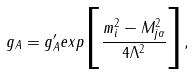<formula> <loc_0><loc_0><loc_500><loc_500>g _ { A } = g _ { A } ^ { \prime } e x p \Big { [ } \frac { m ^ { 2 } _ { i } - M ^ { 2 } _ { j \alpha } } { 4 \Lambda ^ { 2 } } \Big { ] } ,</formula> 